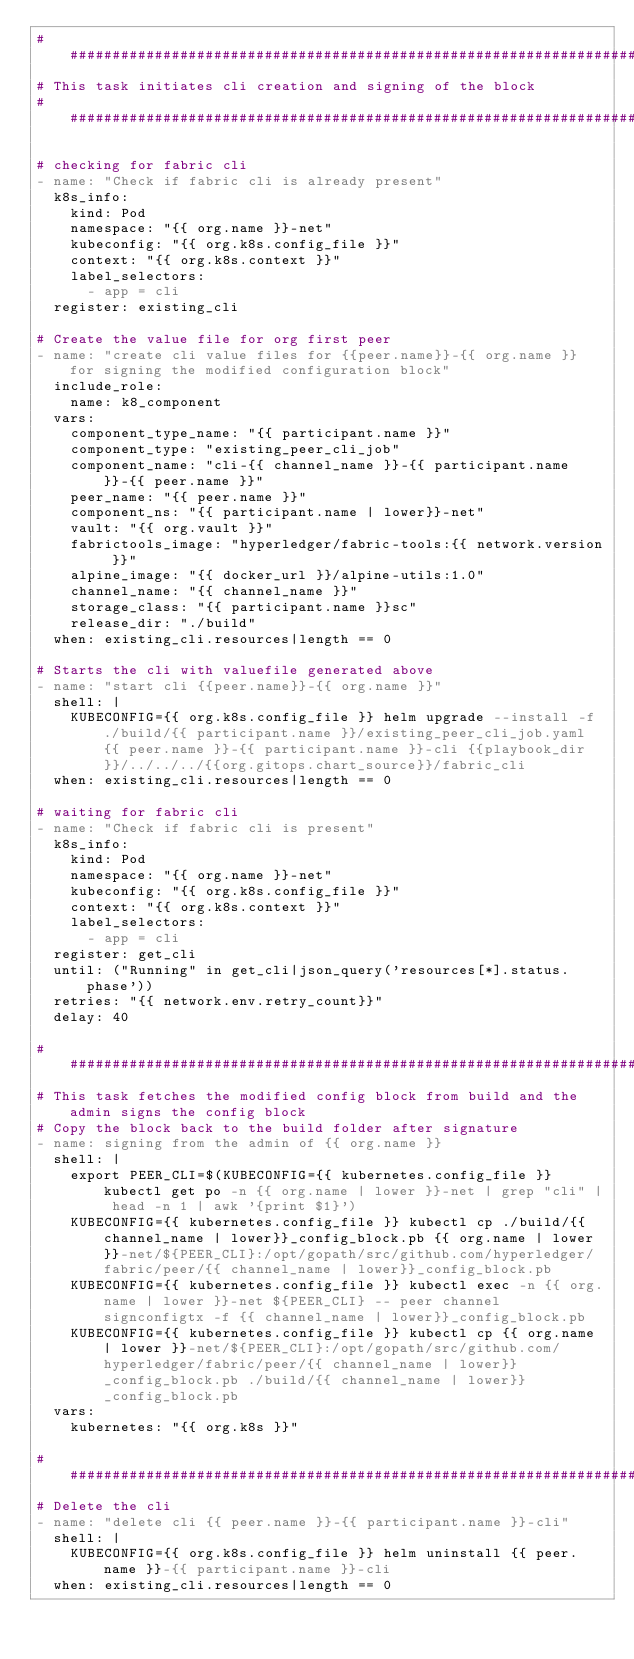<code> <loc_0><loc_0><loc_500><loc_500><_YAML_>############################################################################################
# This task initiates cli creation and signing of the block
############################################################################################

# checking for fabric cli
- name: "Check if fabric cli is already present"
  k8s_info:
    kind: Pod
    namespace: "{{ org.name }}-net"
    kubeconfig: "{{ org.k8s.config_file }}"
    context: "{{ org.k8s.context }}"
    label_selectors:
      - app = cli
  register: existing_cli

# Create the value file for org first peer
- name: "create cli value files for {{peer.name}}-{{ org.name }} for signing the modified configuration block"
  include_role:
    name: k8_component
  vars:
    component_type_name: "{{ participant.name }}"
    component_type: "existing_peer_cli_job"    
    component_name: "cli-{{ channel_name }}-{{ participant.name }}-{{ peer.name }}"
    peer_name: "{{ peer.name }}"
    component_ns: "{{ participant.name | lower}}-net"
    vault: "{{ org.vault }}"
    fabrictools_image: "hyperledger/fabric-tools:{{ network.version }}"
    alpine_image: "{{ docker_url }}/alpine-utils:1.0"
    channel_name: "{{ channel_name }}"
    storage_class: "{{ participant.name }}sc"
    release_dir: "./build"
  when: existing_cli.resources|length == 0

# Starts the cli with valuefile generated above
- name: "start cli {{peer.name}}-{{ org.name }}"
  shell: |
    KUBECONFIG={{ org.k8s.config_file }} helm upgrade --install -f ./build/{{ participant.name }}/existing_peer_cli_job.yaml {{ peer.name }}-{{ participant.name }}-cli {{playbook_dir}}/../../../{{org.gitops.chart_source}}/fabric_cli
  when: existing_cli.resources|length == 0

# waiting for fabric cli
- name: "Check if fabric cli is present"
  k8s_info:
    kind: Pod
    namespace: "{{ org.name }}-net"
    kubeconfig: "{{ org.k8s.config_file }}"
    context: "{{ org.k8s.context }}"
    label_selectors:
      - app = cli
  register: get_cli
  until: ("Running" in get_cli|json_query('resources[*].status.phase'))
  retries: "{{ network.env.retry_count}}"
  delay: 40

############################################################################################
# This task fetches the modified config block from build and the admin signs the config block
# Copy the block back to the build folder after signature
- name: signing from the admin of {{ org.name }}
  shell: |
    export PEER_CLI=$(KUBECONFIG={{ kubernetes.config_file }} kubectl get po -n {{ org.name | lower }}-net | grep "cli" | head -n 1 | awk '{print $1}')
    KUBECONFIG={{ kubernetes.config_file }} kubectl cp ./build/{{ channel_name | lower}}_config_block.pb {{ org.name | lower }}-net/${PEER_CLI}:/opt/gopath/src/github.com/hyperledger/fabric/peer/{{ channel_name | lower}}_config_block.pb
    KUBECONFIG={{ kubernetes.config_file }} kubectl exec -n {{ org.name | lower }}-net ${PEER_CLI} -- peer channel signconfigtx -f {{ channel_name | lower}}_config_block.pb
    KUBECONFIG={{ kubernetes.config_file }} kubectl cp {{ org.name | lower }}-net/${PEER_CLI}:/opt/gopath/src/github.com/hyperledger/fabric/peer/{{ channel_name | lower}}_config_block.pb ./build/{{ channel_name | lower}}_config_block.pb
  vars: 
    kubernetes: "{{ org.k8s }}"

############################################################################################
# Delete the cli   
- name: "delete cli {{ peer.name }}-{{ participant.name }}-cli"
  shell: |
    KUBECONFIG={{ org.k8s.config_file }} helm uninstall {{ peer.name }}-{{ participant.name }}-cli
  when: existing_cli.resources|length == 0
</code> 